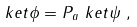Convert formula to latex. <formula><loc_0><loc_0><loc_500><loc_500>\ k e t { \phi } & = P _ { a } \ k e t { \psi } \ ,</formula> 